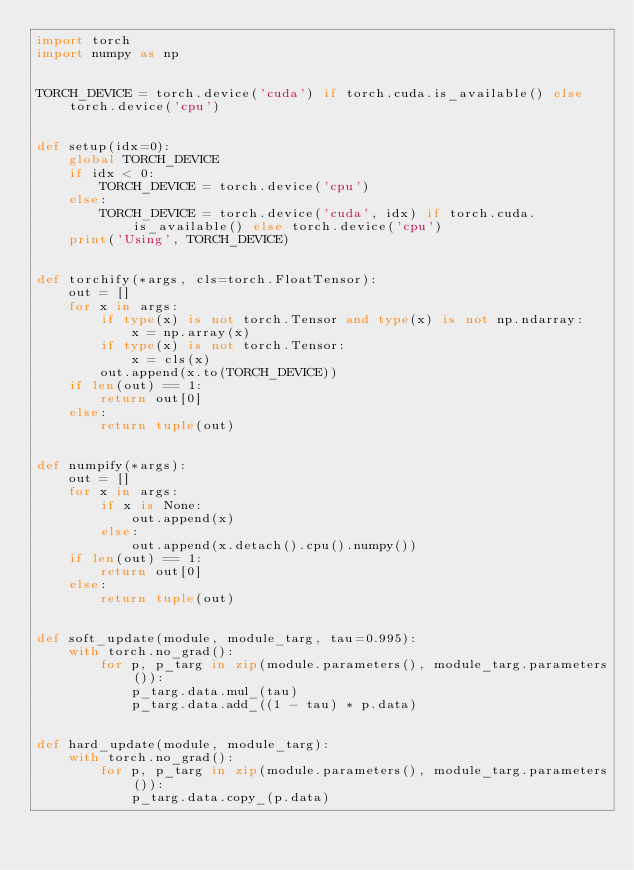Convert code to text. <code><loc_0><loc_0><loc_500><loc_500><_Python_>import torch
import numpy as np


TORCH_DEVICE = torch.device('cuda') if torch.cuda.is_available() else torch.device('cpu')


def setup(idx=0):
    global TORCH_DEVICE
    if idx < 0:
        TORCH_DEVICE = torch.device('cpu')
    else:
        TORCH_DEVICE = torch.device('cuda', idx) if torch.cuda.is_available() else torch.device('cpu')
    print('Using', TORCH_DEVICE)


def torchify(*args, cls=torch.FloatTensor):
    out = []
    for x in args:
        if type(x) is not torch.Tensor and type(x) is not np.ndarray:
            x = np.array(x)
        if type(x) is not torch.Tensor:
            x = cls(x)
        out.append(x.to(TORCH_DEVICE))
    if len(out) == 1:
        return out[0]
    else:
        return tuple(out)


def numpify(*args):
    out = []
    for x in args:
        if x is None:
            out.append(x)
        else:
            out.append(x.detach().cpu().numpy())
    if len(out) == 1:
        return out[0]
    else:
        return tuple(out)


def soft_update(module, module_targ, tau=0.995):
    with torch.no_grad():
        for p, p_targ in zip(module.parameters(), module_targ.parameters()):
            p_targ.data.mul_(tau)
            p_targ.data.add_((1 - tau) * p.data)


def hard_update(module, module_targ):
    with torch.no_grad():
        for p, p_targ in zip(module.parameters(), module_targ.parameters()):
            p_targ.data.copy_(p.data)
</code> 